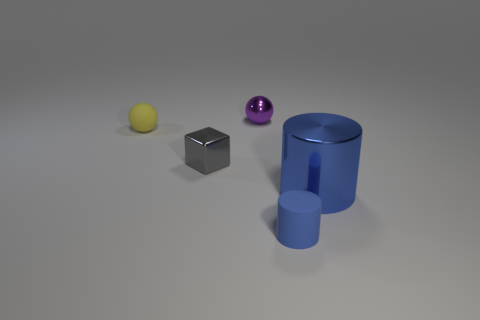There is a tiny rubber thing that is in front of the small gray thing; is its color the same as the big metallic cylinder?
Your answer should be very brief. Yes. There is a object that is both behind the small gray metal thing and to the right of the tiny block; what color is it?
Your answer should be compact. Purple. Are there any balls made of the same material as the small blue object?
Provide a succinct answer. Yes. What size is the yellow object?
Offer a very short reply. Small. What size is the shiny object that is behind the small thing on the left side of the gray thing?
Offer a terse response. Small. There is another blue thing that is the same shape as the large shiny object; what material is it?
Ensure brevity in your answer.  Rubber. What number of cyan shiny cylinders are there?
Provide a short and direct response. 0. What color is the thing that is right of the tiny rubber object that is to the right of the small matte thing behind the tiny gray metallic block?
Offer a terse response. Blue. Are there fewer tiny gray spheres than gray things?
Your response must be concise. Yes. There is a small matte object that is the same shape as the large object; what color is it?
Your answer should be very brief. Blue. 